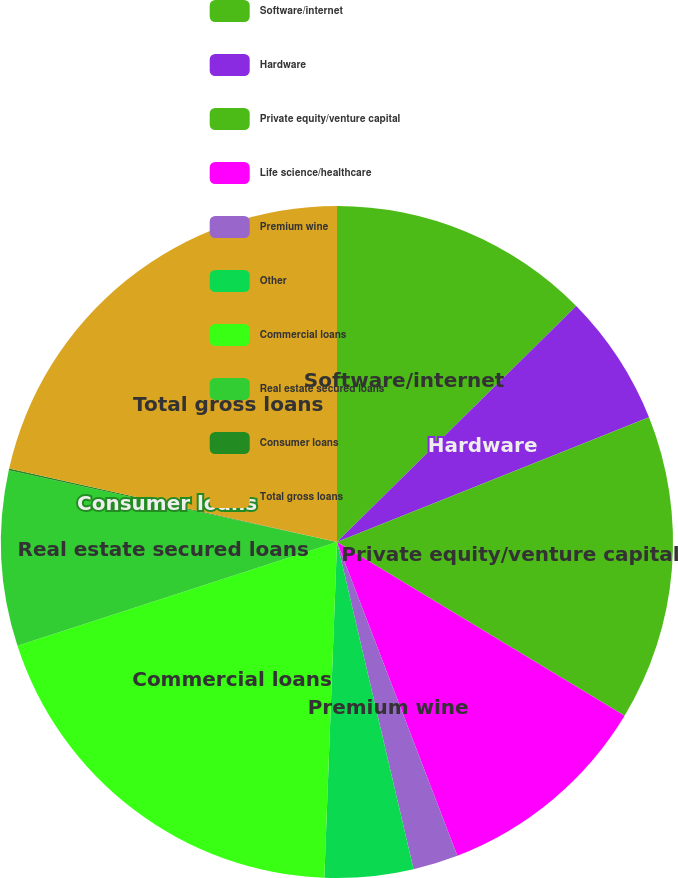<chart> <loc_0><loc_0><loc_500><loc_500><pie_chart><fcel>Software/internet<fcel>Hardware<fcel>Private equity/venture capital<fcel>Life science/healthcare<fcel>Premium wine<fcel>Other<fcel>Commercial loans<fcel>Real estate secured loans<fcel>Consumer loans<fcel>Total gross loans<nl><fcel>12.61%<fcel>6.34%<fcel>14.7%<fcel>10.52%<fcel>2.17%<fcel>4.26%<fcel>19.4%<fcel>8.43%<fcel>0.08%<fcel>21.49%<nl></chart> 